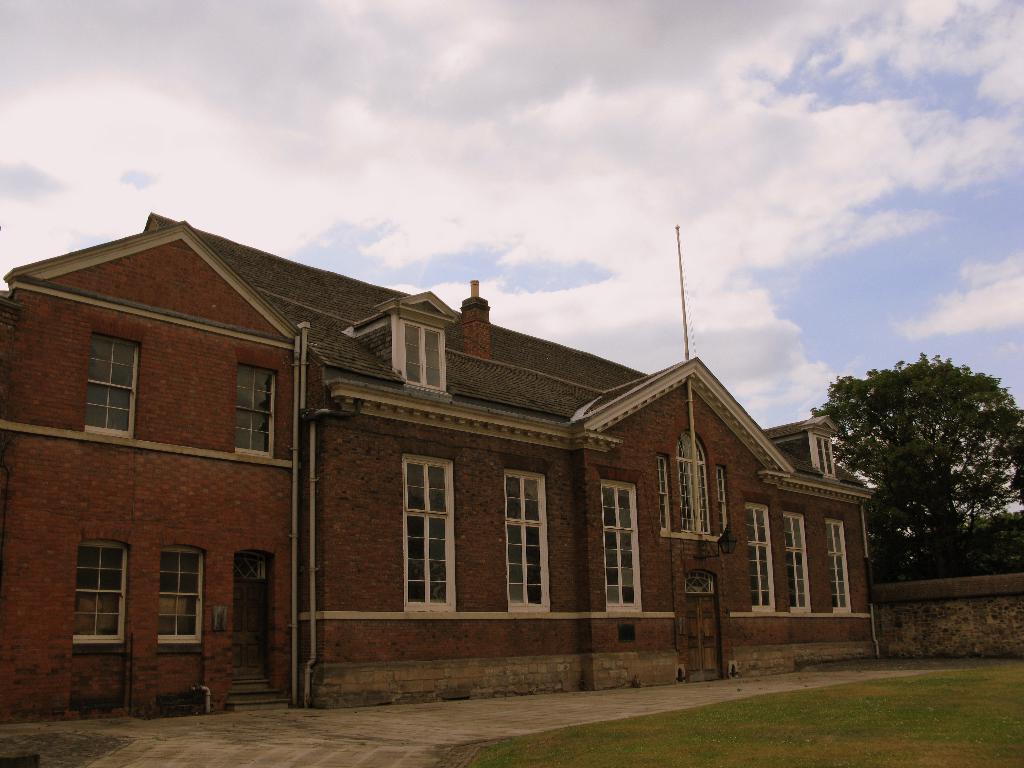Could you give a brief overview of what you see in this image? Here we can see a building,windows,pole,doors,pipes on the wall and on the ground we can see grass and on the right there are trees and a wall. In the background we can see clouds in the sky. 